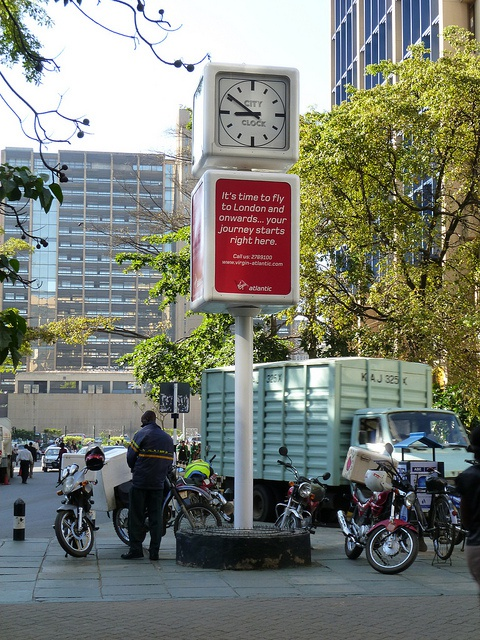Describe the objects in this image and their specific colors. I can see truck in khaki, darkgray, teal, gray, and black tones, clock in khaki, darkgray, gray, black, and lightgray tones, motorcycle in khaki, black, gray, and darkgray tones, people in khaki, black, navy, gray, and blue tones, and motorcycle in khaki, black, gray, blue, and navy tones in this image. 